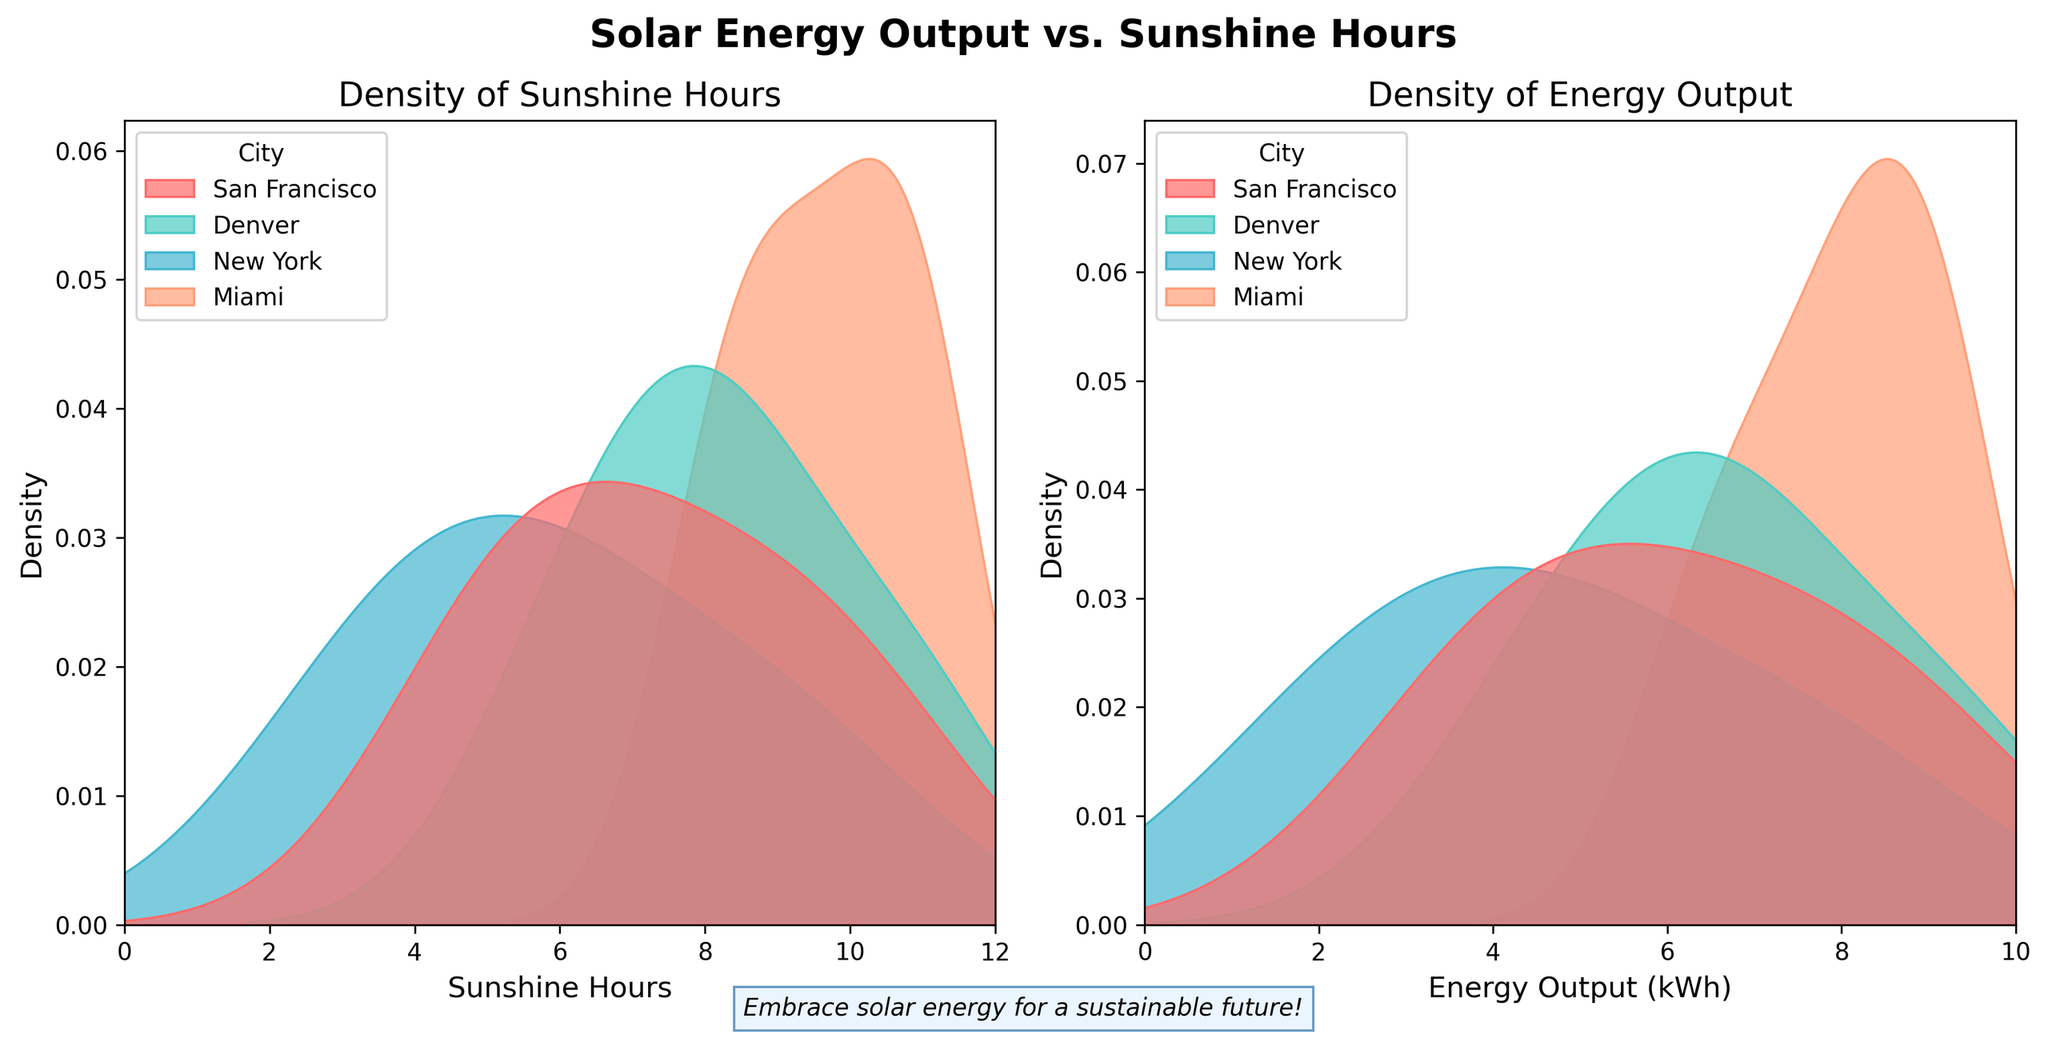What is the main title of the figure? The main title is located at the top center of the figure and it reads "Solar Energy Output vs. Sunshine Hours."
Answer: Solar Energy Output vs. Sunshine Hours What does the x-axis represent in the left subplot? The x-axis in the left subplot is labeled as "Sunshine Hours" which indicates the number of sunshine hours.
Answer: Sunshine Hours What do the different colors in the figure signify? The different colors in the density plots correspond to different cities. Each city is represented by a unique color.
Answer: Different cities Which city appears to have the highest sunshine hours during peak periods? In the left subplot (density of Sunshine Hours), observe the peaks of the density plots. The city with the highest peak during the highest hours (close to 12) is Miami.
Answer: Miami During which season does San Francisco have its highest energy output? By examining the density peak in the right subplot (Energy Output) for San Francisco, we see that the highest energy output peak is in summer (July).
Answer: Summer Which city has the broadest spread in sunshine hours? The spread of the density plot for Sunshine Hours is widest for Miami, as it covers a wide range of hours from around 4 to 11.
Answer: Miami How does the energy output density for New York compare to Miami? The density plot for New York shows lower energy output peaks compared to Miami, indicating that New York has lower energy output on average.
Answer: Lower In general, which variables are being compared in the subplots? The subplots compare Sunshine Hours and Energy Output (kWh). Each subplot represents the density distribution of these variables.
Answer: Sunshine Hours and Energy Output What seasonal pattern can be inferred about Denver's energy output? In the right subplot, Denver’s density peaks illustrate higher energy output in the summer (July), with lower outputs in other seasons.
Answer: Higher in summer Is there a visible correlation between sunshine hours and energy output for the cities? By comparing the densities in both subplots, we observe that higher sunshine hours generally correlate with higher energy output for the cities shown. For instance, summer peaks for the cities align in both sunshine hours and energy output.
Answer: Yes 